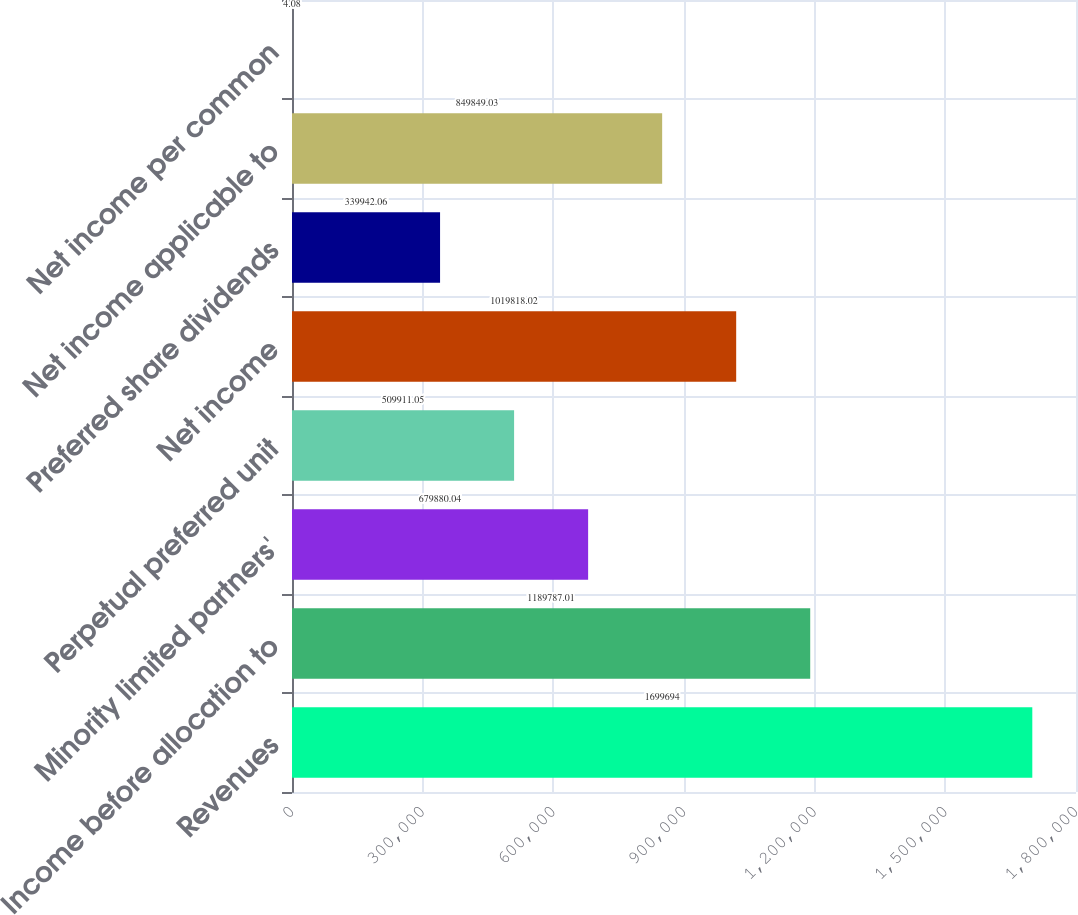Convert chart. <chart><loc_0><loc_0><loc_500><loc_500><bar_chart><fcel>Revenues<fcel>Income before allocation to<fcel>Minority limited partners'<fcel>Perpetual preferred unit<fcel>Net income<fcel>Preferred share dividends<fcel>Net income applicable to<fcel>Net income per common<nl><fcel>1.69969e+06<fcel>1.18979e+06<fcel>679880<fcel>509911<fcel>1.01982e+06<fcel>339942<fcel>849849<fcel>4.08<nl></chart> 